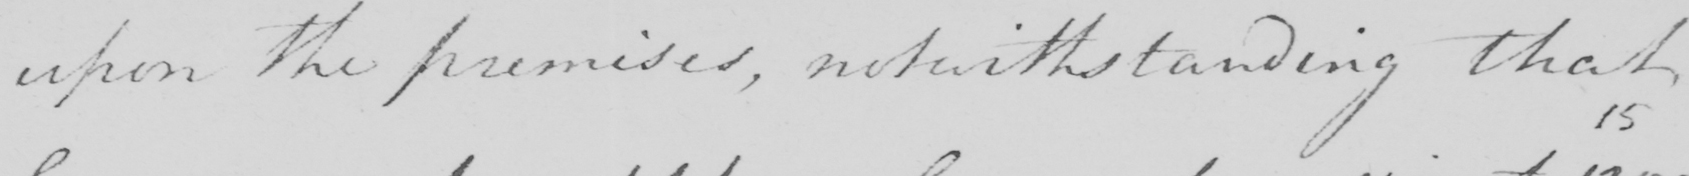Transcribe the text shown in this historical manuscript line. upon the premises , notwithstanding that 